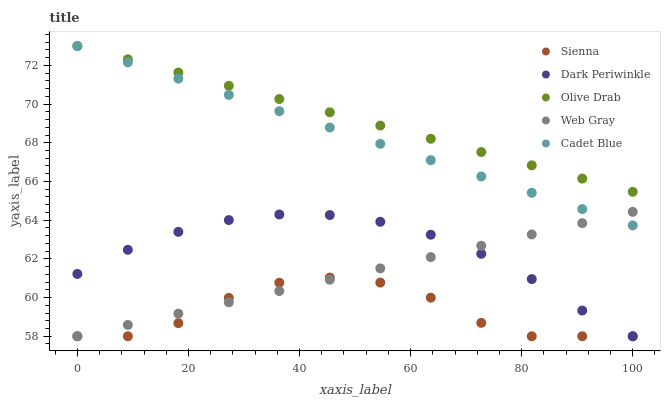Does Sienna have the minimum area under the curve?
Answer yes or no. Yes. Does Olive Drab have the maximum area under the curve?
Answer yes or no. Yes. Does Web Gray have the minimum area under the curve?
Answer yes or no. No. Does Web Gray have the maximum area under the curve?
Answer yes or no. No. Is Cadet Blue the smoothest?
Answer yes or no. Yes. Is Sienna the roughest?
Answer yes or no. Yes. Is Web Gray the smoothest?
Answer yes or no. No. Is Web Gray the roughest?
Answer yes or no. No. Does Sienna have the lowest value?
Answer yes or no. Yes. Does Cadet Blue have the lowest value?
Answer yes or no. No. Does Olive Drab have the highest value?
Answer yes or no. Yes. Does Web Gray have the highest value?
Answer yes or no. No. Is Dark Periwinkle less than Olive Drab?
Answer yes or no. Yes. Is Cadet Blue greater than Sienna?
Answer yes or no. Yes. Does Dark Periwinkle intersect Web Gray?
Answer yes or no. Yes. Is Dark Periwinkle less than Web Gray?
Answer yes or no. No. Is Dark Periwinkle greater than Web Gray?
Answer yes or no. No. Does Dark Periwinkle intersect Olive Drab?
Answer yes or no. No. 